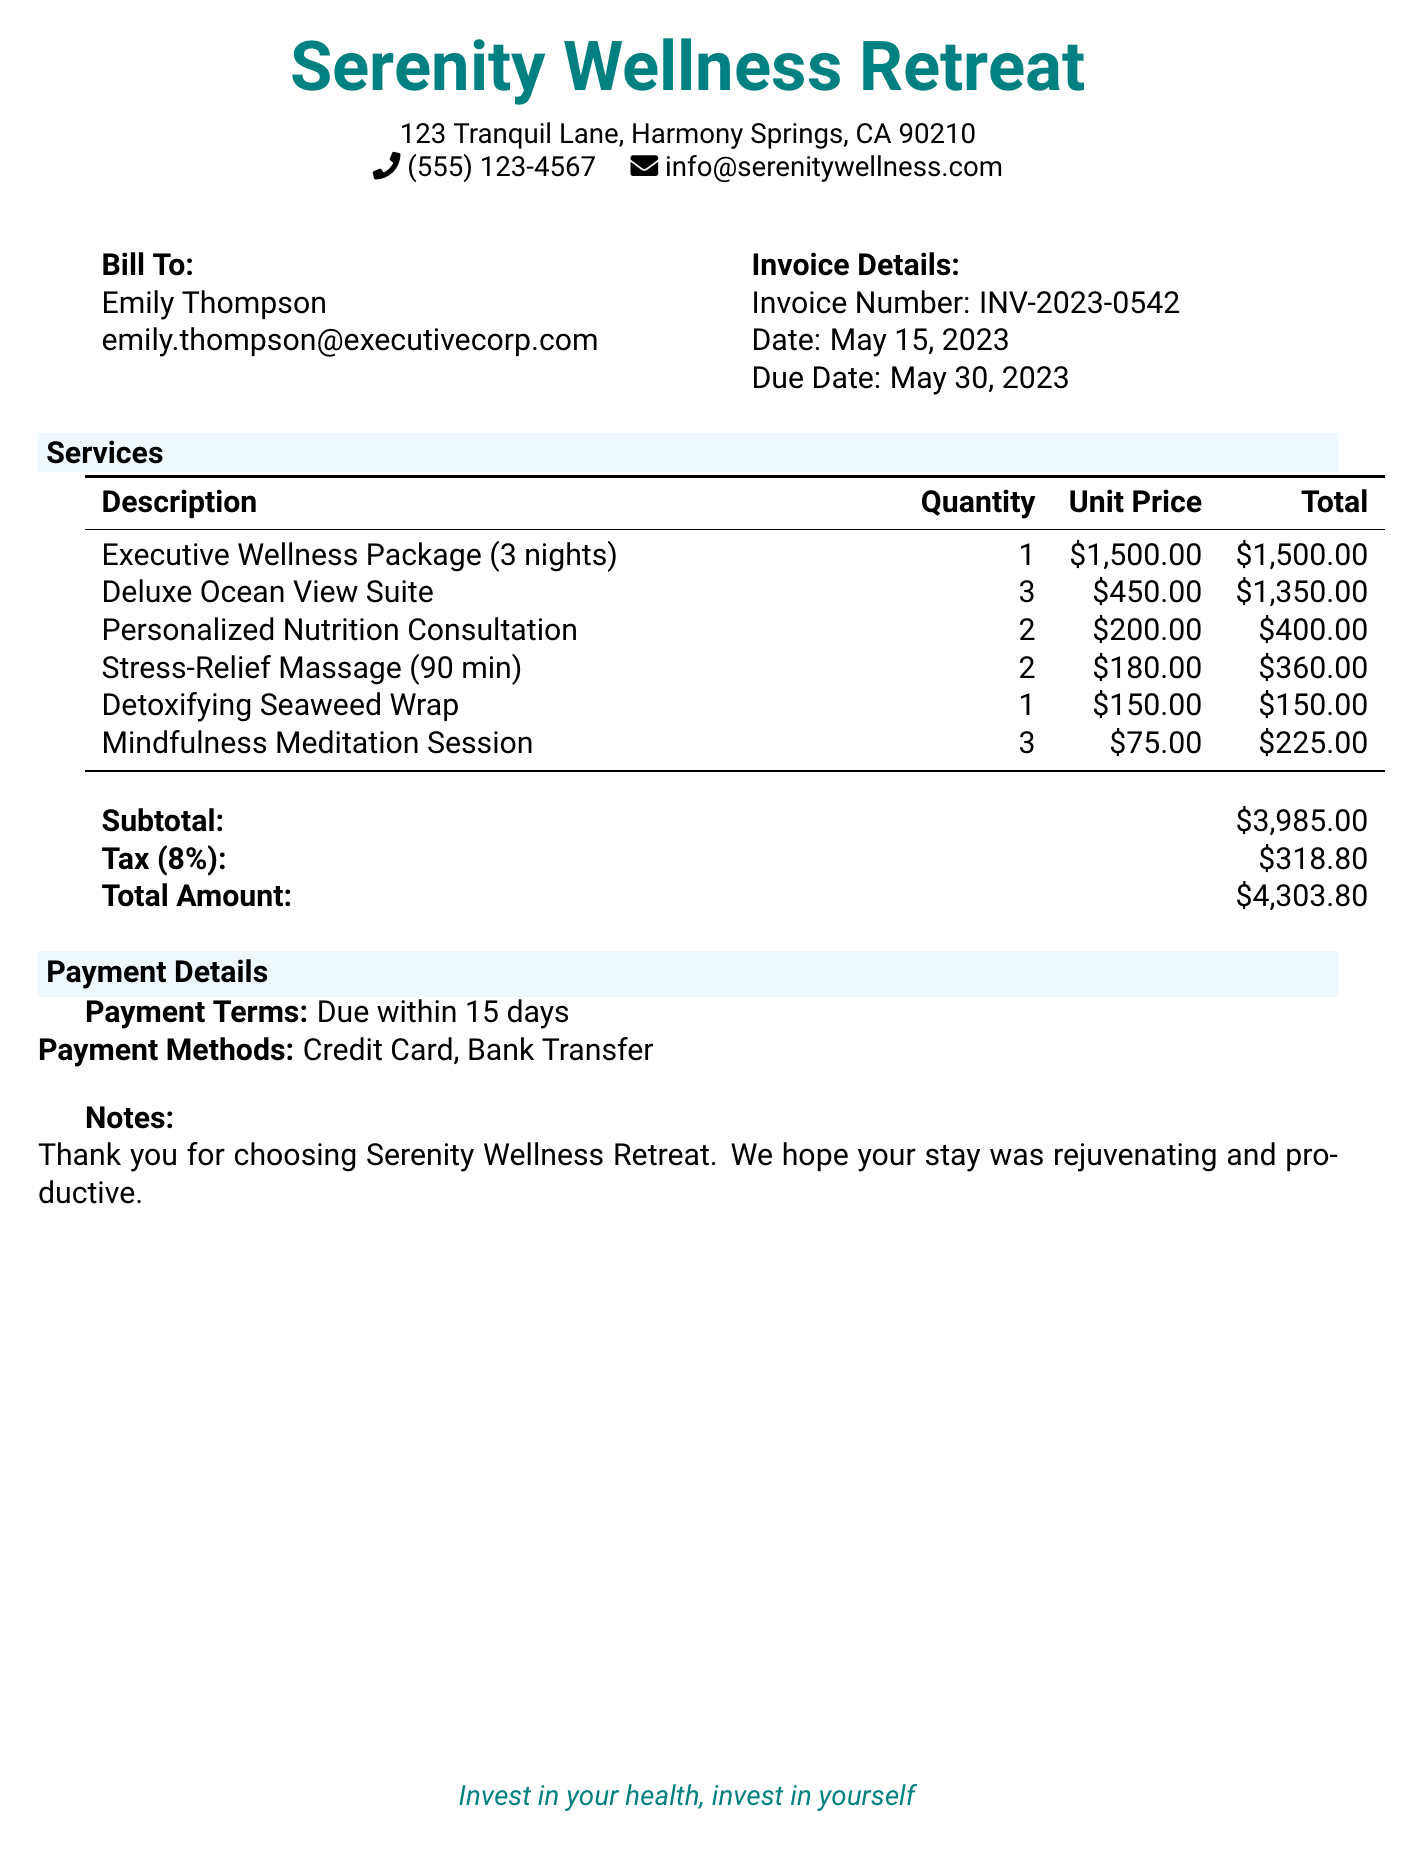What is the total amount due? The total amount due is stated in the invoice section titled "Total Amount," which clearly lists the amount owed as $4,303.80.
Answer: $4,303.80 What is the due date of this invoice? The due date is specified in the "Invoice Details" section of the document, which shows it as May 30, 2023.
Answer: May 30, 2023 How many nights is the Executive Wellness Package for? The description of the Executive Wellness Package mentions it is for 3 nights, which signifies the duration included in the package.
Answer: 3 nights What is the unit price of the Deluxe Ocean View Suite? The invoice lists the unit price for the Deluxe Ocean View Suite in the "Services" section, which is $450.00.
Answer: $450.00 What payment methods are accepted? The "Payment Details" section outlines the payment methods, specifying Credit Card and Bank Transfer as acceptable options.
Answer: Credit Card, Bank Transfer What is the subtotal of services before tax? In the document, the "Subtotal" is provided, reflecting the sum of all services rendered, which is calculated to be $3,985.00.
Answer: $3,985.00 How many Mindfulness Meditation Sessions were provided? The invoice specifies that there are 3 Mindfulness Meditation Sessions listed in the "Services" section, indicating the quantity provided.
Answer: 3 What is the tax rate applied to the subtotal? The tax is mentioned in the invoice as 8%, which is used to calculate the total tax amount applied to the subtotal.
Answer: 8% What is the total cost of the Stress-Relief Massage? The document specifies the total cost of the Stress-Relief Massage under "Services," which lists it as $360.00 for two sessions at $180.00 each.
Answer: $360.00 